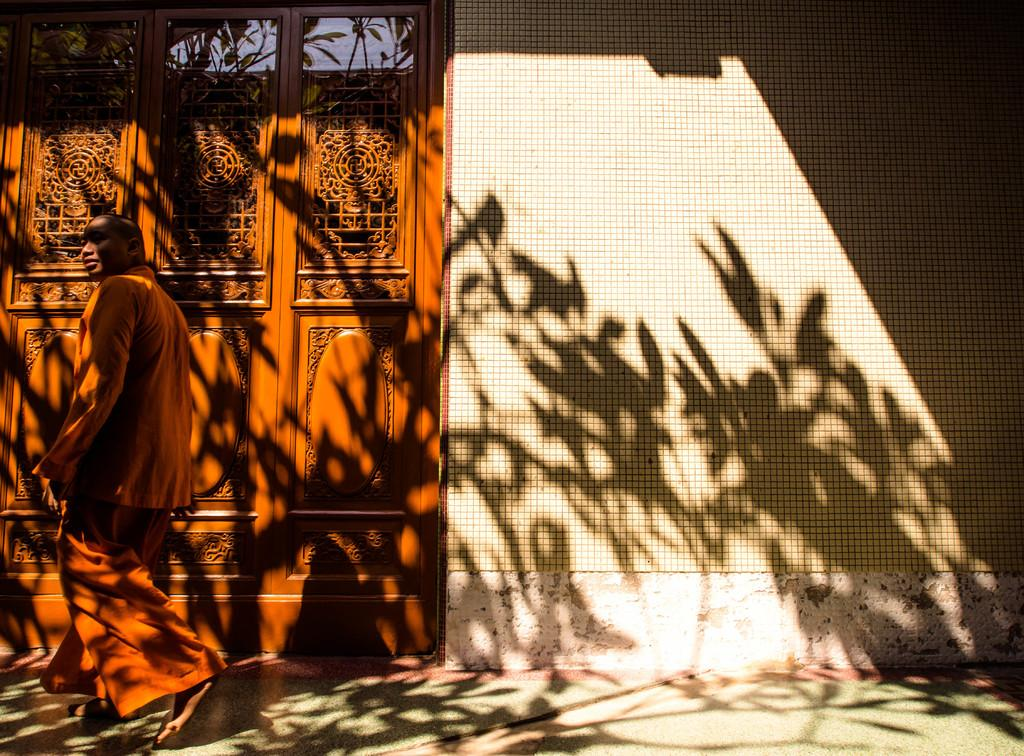Who is present in the image? There is a man in the image. What is the man doing? The man is walking. What can be seen in the background of the image? There are windows, glasses, and a wall in the background of the image. What is at the bottom of the image? There is a road at the bottom of the image. What type of soap is the man using to wash his hands in the image? There is no soap or hand-washing activity present in the image. What type of juice is the man drinking while walking in the image? There is no juice or drinking activity present in the image. 